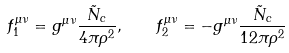Convert formula to latex. <formula><loc_0><loc_0><loc_500><loc_500>f ^ { \mu \nu } _ { 1 } = g ^ { \mu \nu } \frac { \tilde { N } _ { c } } { 4 \pi \rho ^ { 2 } } , \quad f ^ { \mu \nu } _ { 2 } = - g ^ { \mu \nu } \frac { \tilde { N } _ { c } } { 1 2 \pi \rho ^ { 2 } }</formula> 